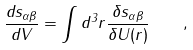<formula> <loc_0><loc_0><loc_500><loc_500>\frac { d { s } _ { \alpha \beta } } { d V } = \int d ^ { 3 } r \frac { \delta { s } _ { \alpha \beta } } { \delta U ( { r } ) } \quad ,</formula> 